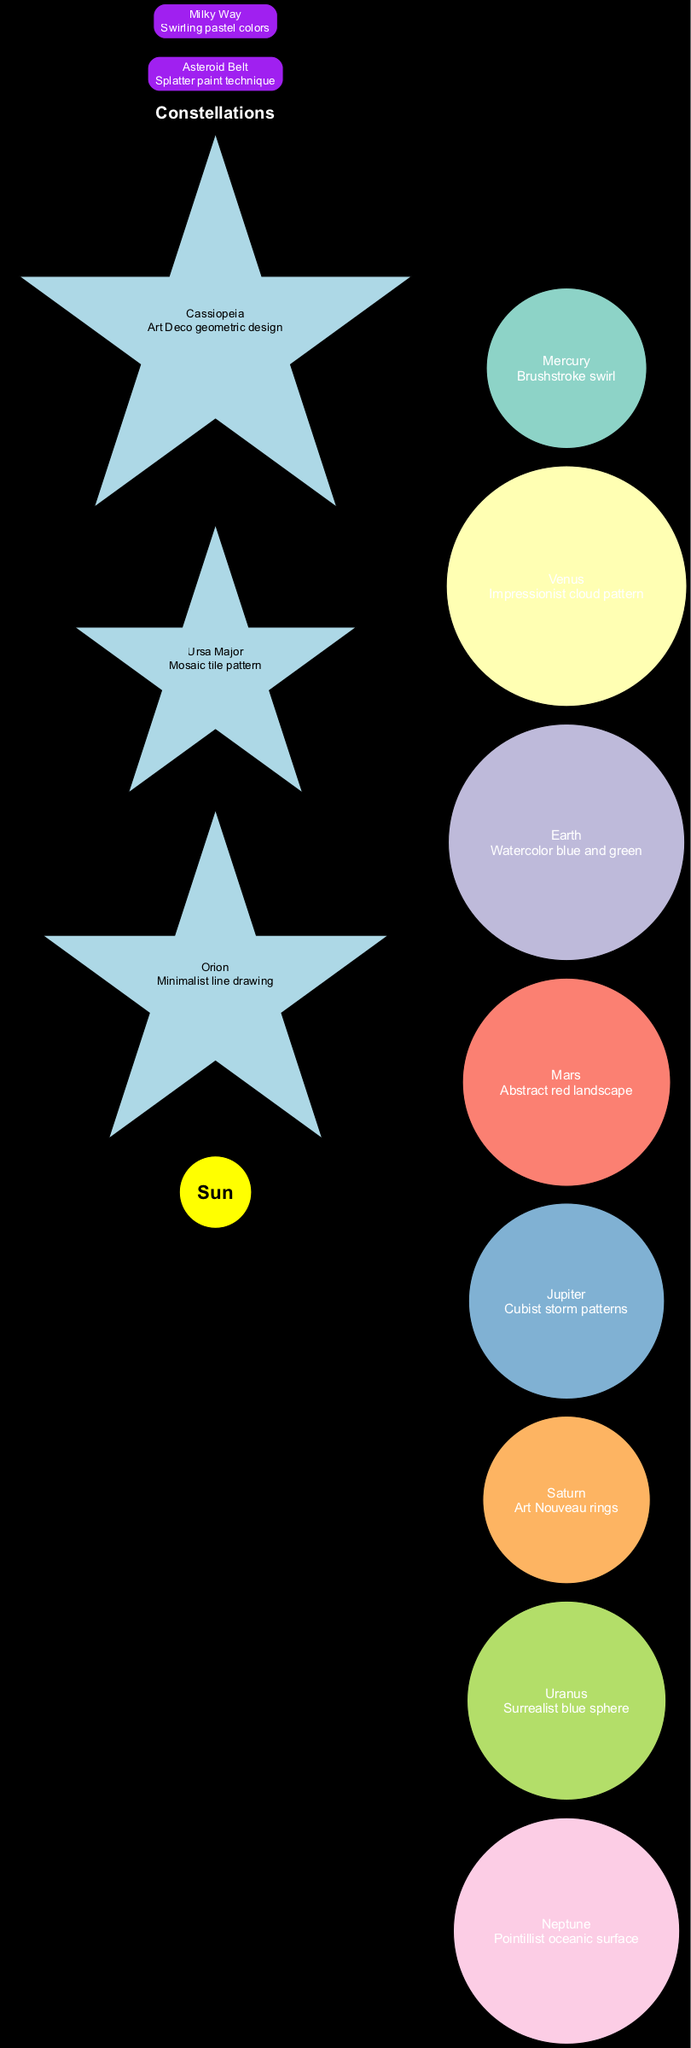What is the artistic representation of Mars? The node for Mars indicates the artistic representation as "Abstract red landscape." This is found directly by reading the label for the node corresponding to Mars.
Answer: Abstract red landscape How many planets are depicted in the diagram? The planets are listed in the data, and there are a total of eight planets mentioned. By counting each entry, we find that there are eight distinct planets shown.
Answer: 8 Which constellation has an Art Deco geometric design? By examining the constellations in the diagram, Cassiopeia is noted as having the artistic representation "Art Deco geometric design." This is found in the specific details for Cassiopeia's node.
Answer: Cassiopeia Which planet is represented with Cubist storm patterns? The node for Jupiter shows "Cubist storm patterns" as its artistic representation. The answer comes from identifying the details associated with Jupiter in the diagram.
Answer: Jupiter What color representation is used for Earth? The artistic representation for Earth is shown as "Watercolor blue and green," available directly from the node information.
Answer: Watercolor blue and green Which element has a splatter paint technique? The Asteroid Belt node specifies the artistic representation as "Splatter paint technique." Thus, the answer is directly identified from that specific node detail.
Answer: Asteroid Belt Which planet is closest to the Sun? Mercury is the planet closest to the Sun, directly implied by the positioning of the edges leading from the Sun to the planets arranged in order.
Answer: Mercury What color scheme is used for the Milky Way? The node for the Milky Way describes its artistic representation as "Swirling pastel colors." This information can be simply obtained by viewing the node for Milky Way in the diagram.
Answer: Swirling pastel colors How is Saturn artistically represented? Saturn’s artistic representation is given as "Art Nouveau rings," which is found by directly reading the Saturn node.
Answer: Art Nouveau rings 